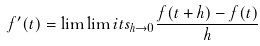<formula> <loc_0><loc_0><loc_500><loc_500>f ^ { \prime } ( t ) = \lim \lim i t s _ { h \rightarrow 0 } \frac { f ( t + h ) - f ( t ) } { h }</formula> 